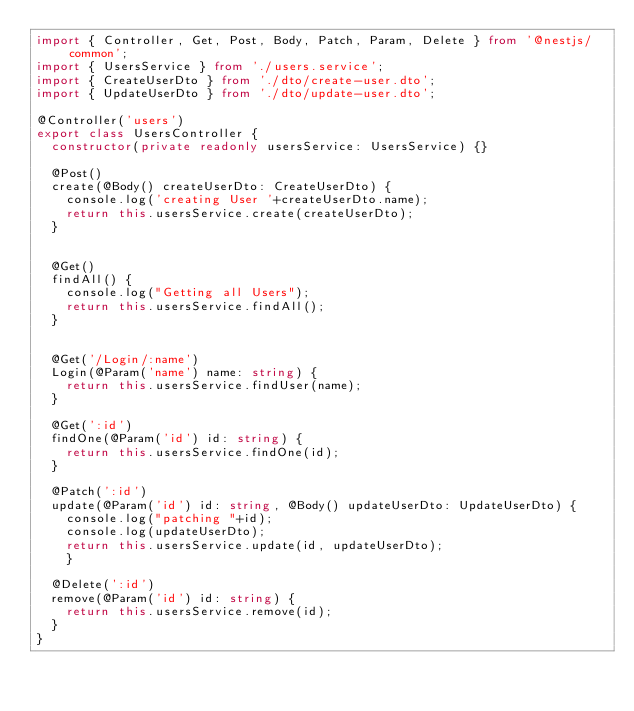<code> <loc_0><loc_0><loc_500><loc_500><_TypeScript_>import { Controller, Get, Post, Body, Patch, Param, Delete } from '@nestjs/common';
import { UsersService } from './users.service';
import { CreateUserDto } from './dto/create-user.dto';
import { UpdateUserDto } from './dto/update-user.dto';

@Controller('users')
export class UsersController {
  constructor(private readonly usersService: UsersService) {}

  @Post()
  create(@Body() createUserDto: CreateUserDto) {
    console.log('creating User '+createUserDto.name);
    return this.usersService.create(createUserDto);
  }


  @Get()
  findAll() {
    console.log("Getting all Users");
    return this.usersService.findAll();
  }


  @Get('/Login/:name')
  Login(@Param('name') name: string) {
    return this.usersService.findUser(name);
  }

  @Get(':id')
  findOne(@Param('id') id: string) {
    return this.usersService.findOne(id);
  }

  @Patch(':id')
  update(@Param('id') id: string, @Body() updateUserDto: UpdateUserDto) {
    console.log("patching "+id);
    console.log(updateUserDto);
    return this.usersService.update(id, updateUserDto);
    }

  @Delete(':id')
  remove(@Param('id') id: string) {
    return this.usersService.remove(id);
  }
}
</code> 